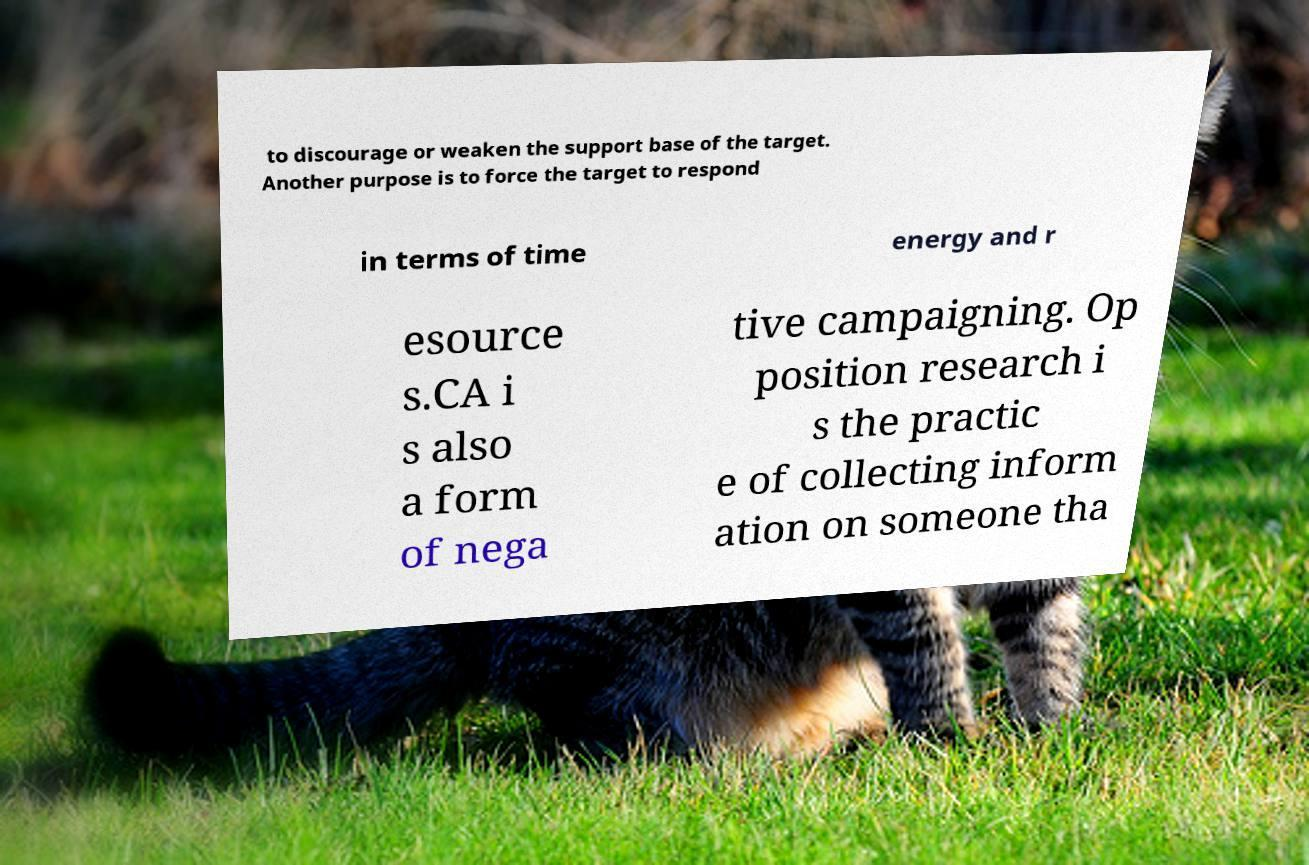I need the written content from this picture converted into text. Can you do that? to discourage or weaken the support base of the target. Another purpose is to force the target to respond in terms of time energy and r esource s.CA i s also a form of nega tive campaigning. Op position research i s the practic e of collecting inform ation on someone tha 